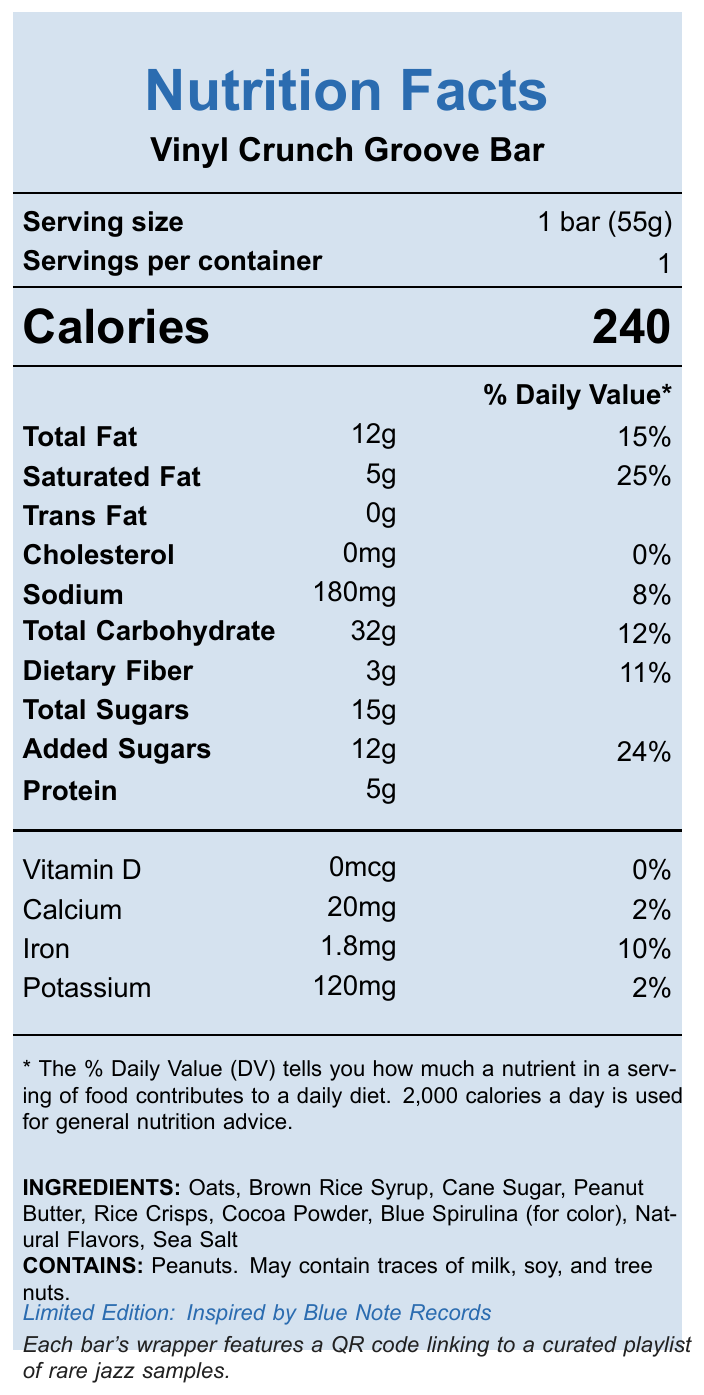what is the serving size of the Vinyl Crunch Groove Bar? The document specifies the serving size as "1 bar (55g)" under the Serving Information section.
Answer: 1 bar (55g) How many calories are in one Vinyl Crunch Groove Bar? The Calorie information in the document lists that there are 240 calories per bar.
Answer: 240 How much total fat does one bar contain? Under the Nutrient Information section, it states that Total Fat is 12g, which is 15% of the daily value.
Answer: 12g How much sodium is in the Vinyl Crunch Groove Bar? The Nutrient Information section shows that Sodium content is 180mg, which is 8% of the daily value.
Answer: 180mg What are the main ingredients of the Vinyl Crunch Groove Bar? The Ingredients section lists all these ingredients.
Answer: Oats, Brown Rice Syrup, Cane Sugar, Peanut Butter, Rice Crisps, Cocoa Powder, Blue Spirulina (for color), Natural Flavors, Sea Salt Which company manufactures the Vinyl Crunch Groove Bar? A. Nutrition Inc. B. Groove Nutrition Labs C. Snack Co. D. Protein Bars Ltd. The Manufacturer information states "Groove Nutrition Labs".
Answer: B What is the percentage daily value of added sugars in one bar? A. 15% B. 20% C. 24% D. 30% The Added Sugars' daily value is listed as 24%.
Answer: C Does the bar contain any Vitamin D? The document states that the amount of Vitamin D is 0mcg, with a daily value of 0%.
Answer: No Summarize the main idea of the document. The document is a nutritional label for the Vinyl Crunch Groove Bar, detailing the serving size, calorie count, nutritional information for fats, carbohydrates, proteins, and vitamins, along with ingredients and allergen details. It highlights that the snack bar is a limited edition inspired by Blue Note Records and includes a QR code for a curated jazz playlist.
Answer: The Vinyl Crunch Groove Bar Nutrition Facts Label provides detailed information about the calorie content, nutrient composition including fats, carbohydrates, proteins, vitamins, minerals, and the ingredients. It also notes allergen information and mentions that the bar is a limited edition inspired by Blue Note Records, with a QR code on the wrapper for a jazz playlist. What are the allergens present in the Vinyl Crunch Groove Bar? The Allergen Information section states that the bar contains peanuts and may have traces of milk, soy, and tree nuts.
Answer: Peanuts. May contain traces of milk, soy, and tree nuts. Can you determine whether the bar contains gluten from the information provided? The document does not provide any information about the presence or absence of gluten.
Answer: Cannot be determined How many grams of protein does the Vinyl Crunch Groove Bar have? The Nutrient Information section lists Protein at 5g.
Answer: 5g Is there a QR code on the wrapper of the Vinyl Crunch Groove Bar? The Music Fact states that each bar's wrapper features a QR code linking to a curated playlist of rare jazz samples.
Answer: Yes How much Calcium does the Vinyl Crunch Groove Bar contain? The Vitamin and Mineral Information section lists Calcium at 20mg, which is 2% of the daily value.
Answer: 20mg 